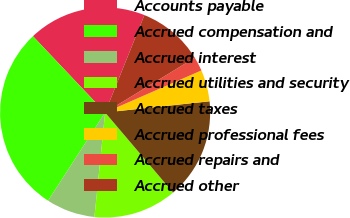Convert chart. <chart><loc_0><loc_0><loc_500><loc_500><pie_chart><fcel>Accounts payable<fcel>Accrued compensation and<fcel>Accrued interest<fcel>Accrued utilities and security<fcel>Accrued taxes<fcel>Accrued professional fees<fcel>Accrued repairs and<fcel>Accrued other<nl><fcel>18.16%<fcel>28.81%<fcel>7.51%<fcel>12.83%<fcel>15.5%<fcel>4.85%<fcel>2.18%<fcel>10.17%<nl></chart> 